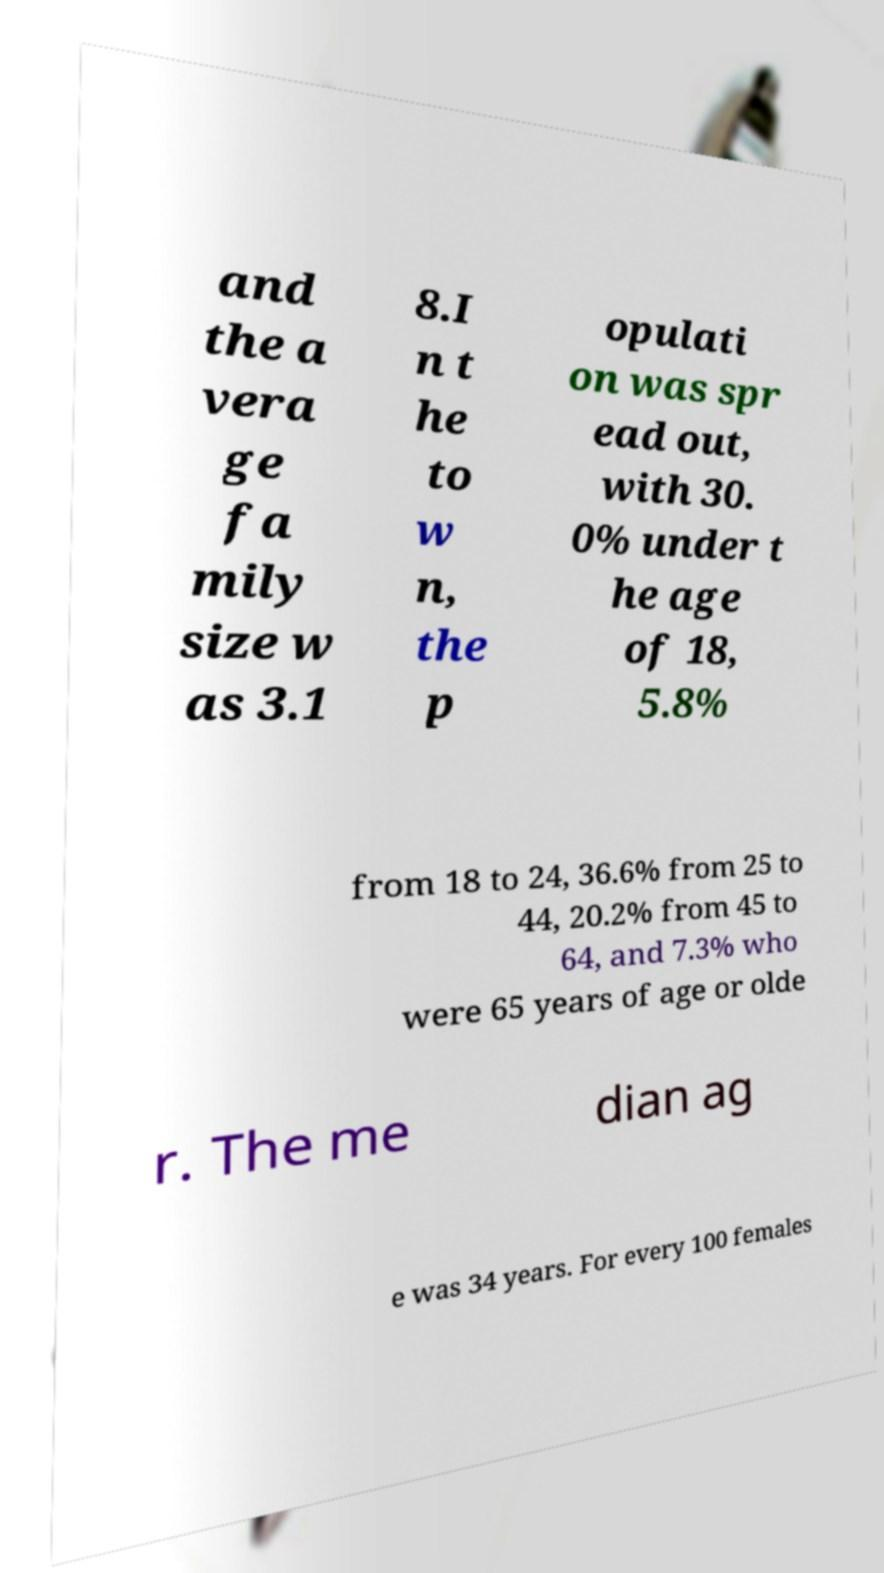Could you extract and type out the text from this image? and the a vera ge fa mily size w as 3.1 8.I n t he to w n, the p opulati on was spr ead out, with 30. 0% under t he age of 18, 5.8% from 18 to 24, 36.6% from 25 to 44, 20.2% from 45 to 64, and 7.3% who were 65 years of age or olde r. The me dian ag e was 34 years. For every 100 females 